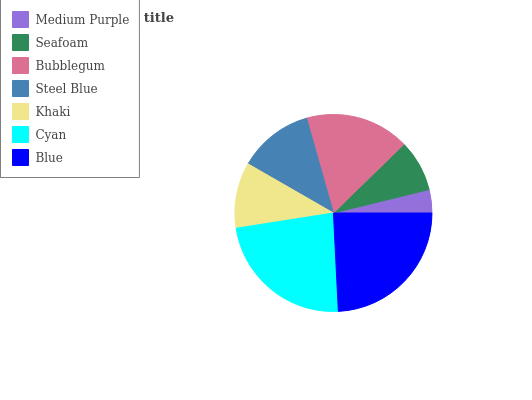Is Medium Purple the minimum?
Answer yes or no. Yes. Is Blue the maximum?
Answer yes or no. Yes. Is Seafoam the minimum?
Answer yes or no. No. Is Seafoam the maximum?
Answer yes or no. No. Is Seafoam greater than Medium Purple?
Answer yes or no. Yes. Is Medium Purple less than Seafoam?
Answer yes or no. Yes. Is Medium Purple greater than Seafoam?
Answer yes or no. No. Is Seafoam less than Medium Purple?
Answer yes or no. No. Is Steel Blue the high median?
Answer yes or no. Yes. Is Steel Blue the low median?
Answer yes or no. Yes. Is Khaki the high median?
Answer yes or no. No. Is Khaki the low median?
Answer yes or no. No. 